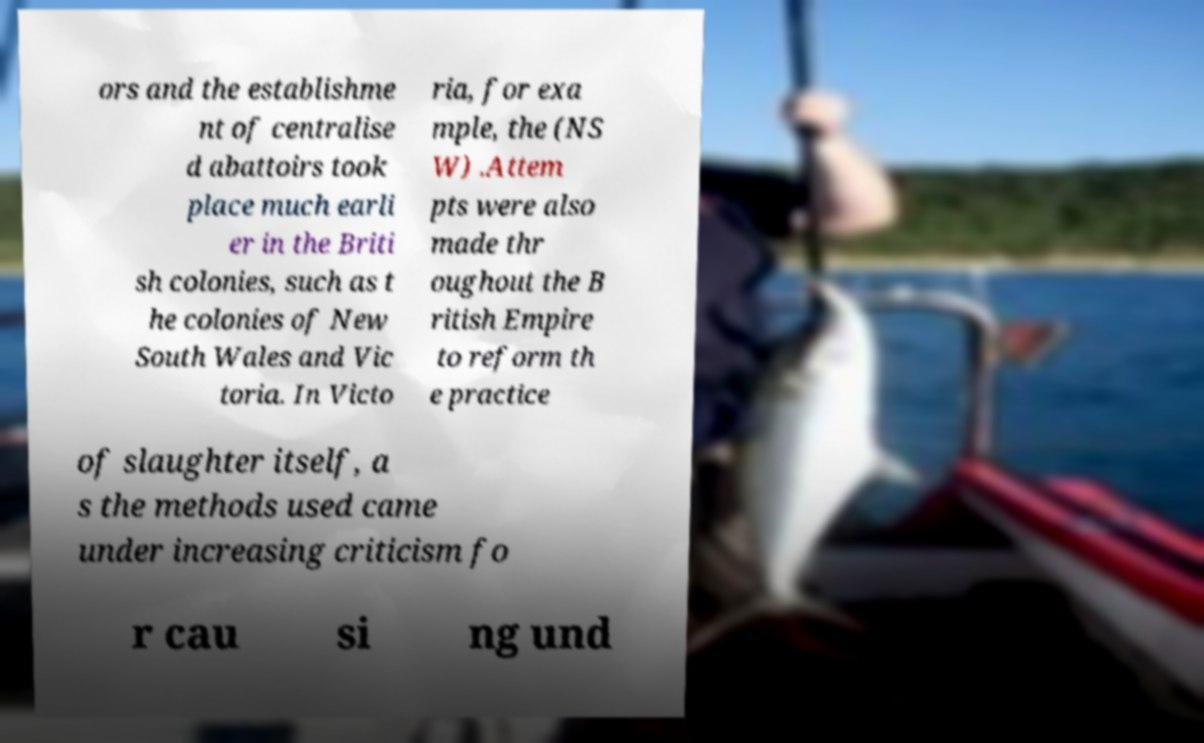Please identify and transcribe the text found in this image. ors and the establishme nt of centralise d abattoirs took place much earli er in the Briti sh colonies, such as t he colonies of New South Wales and Vic toria. In Victo ria, for exa mple, the (NS W) .Attem pts were also made thr oughout the B ritish Empire to reform th e practice of slaughter itself, a s the methods used came under increasing criticism fo r cau si ng und 